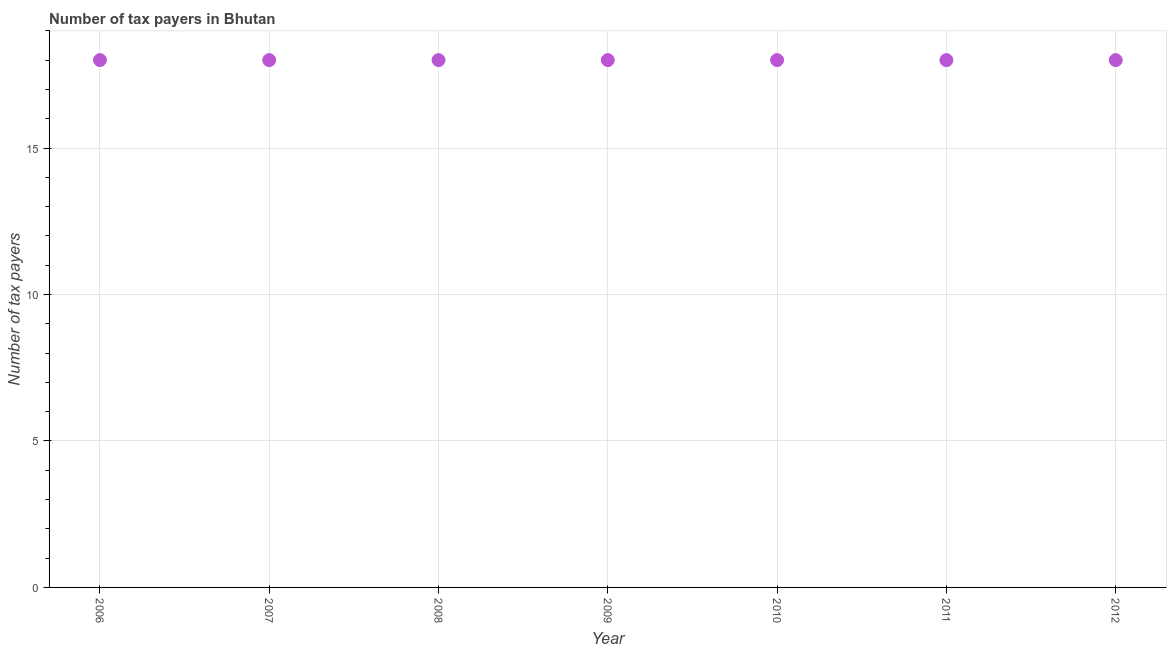What is the number of tax payers in 2010?
Provide a succinct answer. 18. Across all years, what is the maximum number of tax payers?
Make the answer very short. 18. Across all years, what is the minimum number of tax payers?
Make the answer very short. 18. What is the sum of the number of tax payers?
Your answer should be compact. 126. What is the median number of tax payers?
Provide a short and direct response. 18. In how many years, is the number of tax payers greater than 13 ?
Provide a succinct answer. 7. What is the ratio of the number of tax payers in 2010 to that in 2011?
Make the answer very short. 1. Is the difference between the number of tax payers in 2010 and 2011 greater than the difference between any two years?
Make the answer very short. Yes. What is the difference between the highest and the second highest number of tax payers?
Offer a very short reply. 0. Is the sum of the number of tax payers in 2006 and 2012 greater than the maximum number of tax payers across all years?
Give a very brief answer. Yes. In how many years, is the number of tax payers greater than the average number of tax payers taken over all years?
Your answer should be very brief. 0. How many years are there in the graph?
Provide a succinct answer. 7. Does the graph contain any zero values?
Your answer should be compact. No. Does the graph contain grids?
Ensure brevity in your answer.  Yes. What is the title of the graph?
Provide a succinct answer. Number of tax payers in Bhutan. What is the label or title of the Y-axis?
Provide a succinct answer. Number of tax payers. What is the Number of tax payers in 2006?
Make the answer very short. 18. What is the Number of tax payers in 2008?
Keep it short and to the point. 18. What is the Number of tax payers in 2009?
Your answer should be compact. 18. What is the Number of tax payers in 2010?
Make the answer very short. 18. What is the Number of tax payers in 2011?
Ensure brevity in your answer.  18. What is the Number of tax payers in 2012?
Provide a succinct answer. 18. What is the difference between the Number of tax payers in 2006 and 2009?
Give a very brief answer. 0. What is the difference between the Number of tax payers in 2006 and 2010?
Provide a succinct answer. 0. What is the difference between the Number of tax payers in 2007 and 2008?
Your answer should be compact. 0. What is the difference between the Number of tax payers in 2007 and 2009?
Offer a very short reply. 0. What is the difference between the Number of tax payers in 2007 and 2010?
Ensure brevity in your answer.  0. What is the difference between the Number of tax payers in 2007 and 2011?
Provide a short and direct response. 0. What is the difference between the Number of tax payers in 2007 and 2012?
Your response must be concise. 0. What is the difference between the Number of tax payers in 2008 and 2009?
Offer a very short reply. 0. What is the difference between the Number of tax payers in 2008 and 2010?
Give a very brief answer. 0. What is the difference between the Number of tax payers in 2009 and 2012?
Ensure brevity in your answer.  0. What is the difference between the Number of tax payers in 2010 and 2011?
Keep it short and to the point. 0. What is the ratio of the Number of tax payers in 2006 to that in 2007?
Keep it short and to the point. 1. What is the ratio of the Number of tax payers in 2006 to that in 2010?
Your answer should be compact. 1. What is the ratio of the Number of tax payers in 2006 to that in 2011?
Give a very brief answer. 1. What is the ratio of the Number of tax payers in 2006 to that in 2012?
Your response must be concise. 1. What is the ratio of the Number of tax payers in 2007 to that in 2009?
Provide a short and direct response. 1. What is the ratio of the Number of tax payers in 2007 to that in 2012?
Offer a very short reply. 1. What is the ratio of the Number of tax payers in 2008 to that in 2009?
Provide a short and direct response. 1. What is the ratio of the Number of tax payers in 2008 to that in 2012?
Provide a succinct answer. 1. What is the ratio of the Number of tax payers in 2009 to that in 2011?
Offer a terse response. 1. What is the ratio of the Number of tax payers in 2009 to that in 2012?
Your response must be concise. 1. 